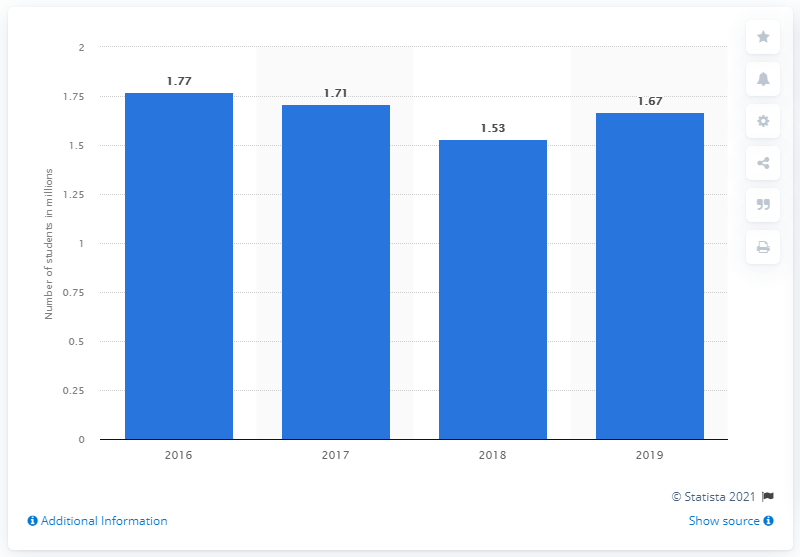Indicate a few pertinent items in this graphic. In 2019, there were approximately 1.67 million university students in Vietnam. 